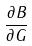Convert formula to latex. <formula><loc_0><loc_0><loc_500><loc_500>\frac { \partial B } { \partial G }</formula> 